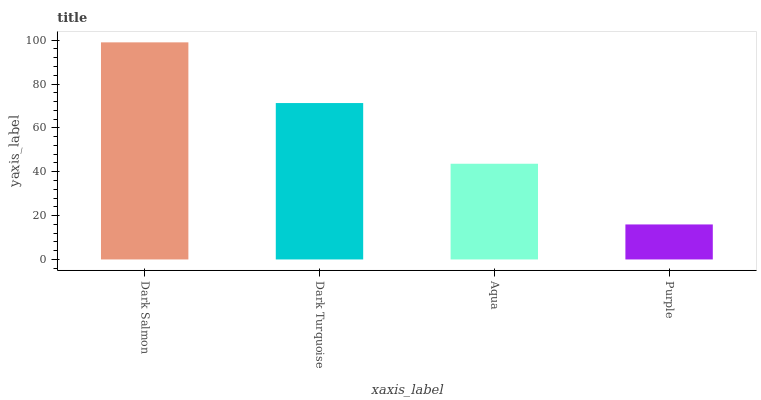Is Purple the minimum?
Answer yes or no. Yes. Is Dark Salmon the maximum?
Answer yes or no. Yes. Is Dark Turquoise the minimum?
Answer yes or no. No. Is Dark Turquoise the maximum?
Answer yes or no. No. Is Dark Salmon greater than Dark Turquoise?
Answer yes or no. Yes. Is Dark Turquoise less than Dark Salmon?
Answer yes or no. Yes. Is Dark Turquoise greater than Dark Salmon?
Answer yes or no. No. Is Dark Salmon less than Dark Turquoise?
Answer yes or no. No. Is Dark Turquoise the high median?
Answer yes or no. Yes. Is Aqua the low median?
Answer yes or no. Yes. Is Dark Salmon the high median?
Answer yes or no. No. Is Dark Salmon the low median?
Answer yes or no. No. 